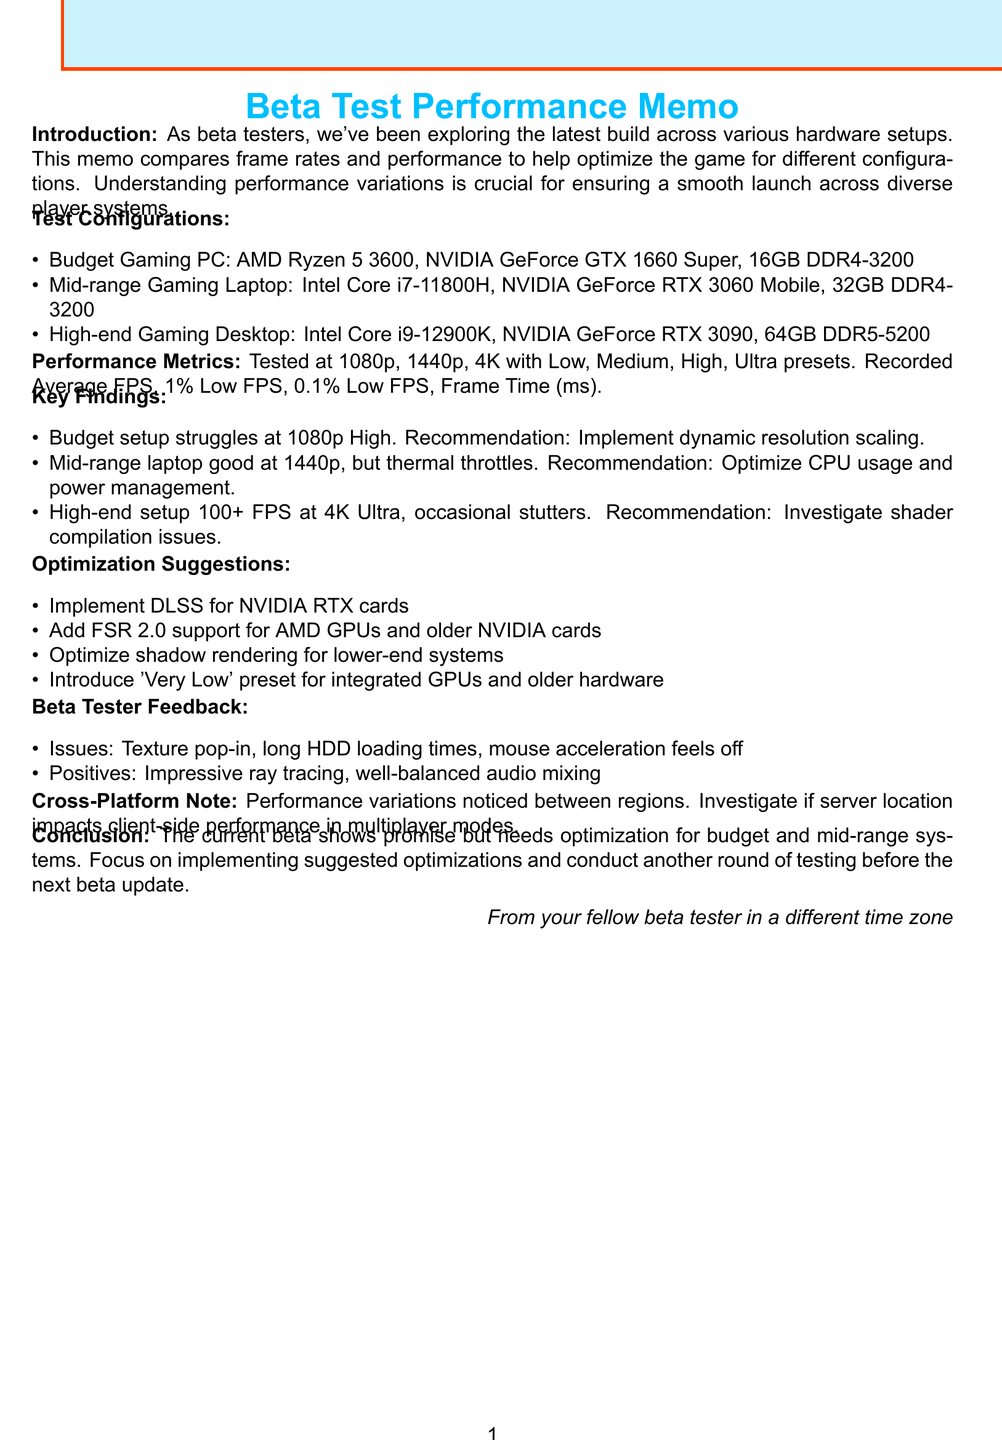What CPU is in the Budget Gaming PC? The document lists the hardware configuration for the Budget Gaming PC, stating it uses an AMD Ryzen 5 3600 CPU.
Answer: AMD Ryzen 5 3600 What resolution is the Mid-range Gaming Laptop tested at? The document indicates that performance metrics were tested at 1080p, 1440p, and 4K, including for the Mid-range Gaming Laptop.
Answer: 1440p How many GB of RAM does the High-end Gaming Desktop have? The configuration section specifies that the High-end Gaming Desktop has 64GB DDR5-5200 of RAM.
Answer: 64GB DDR5-5200 What performance issue is noted for the budget setup? The document states that the budget setup struggles to maintain 60 FPS at 1080p on High settings.
Answer: Struggles to maintain 60 FPS at 1080p on High Which optimization suggestion is mentioned for older hardware? The document includes a suggestion to introduce a 'Very Low' preset for integrated GPUs and older hardware.
Answer: Introduce a 'Very Low' preset What common issue does the beta tester feedback mention? The feedback section lists texture pop-in on fast travel as one common issue experienced by beta testers.
Answer: Texture pop-in on fast travel What is the main conclusion regarding the current beta build? The conclusion summarizes that the current beta build shows promise but needs optimization for budget and mid-range systems.
Answer: Needs optimization for budget and mid-range systems What is the recommendation for the high-end setup? The document suggests investigating potential shader compilation issues causing frame time spikes for the high-end setup.
Answer: Investigate potential shader compilation issues Does the memo mention any specific feedback about audio? Positive notes in the feedback section highlight that audio mixing is well-balanced across different system configurations.
Answer: Well-balanced audio mixing 